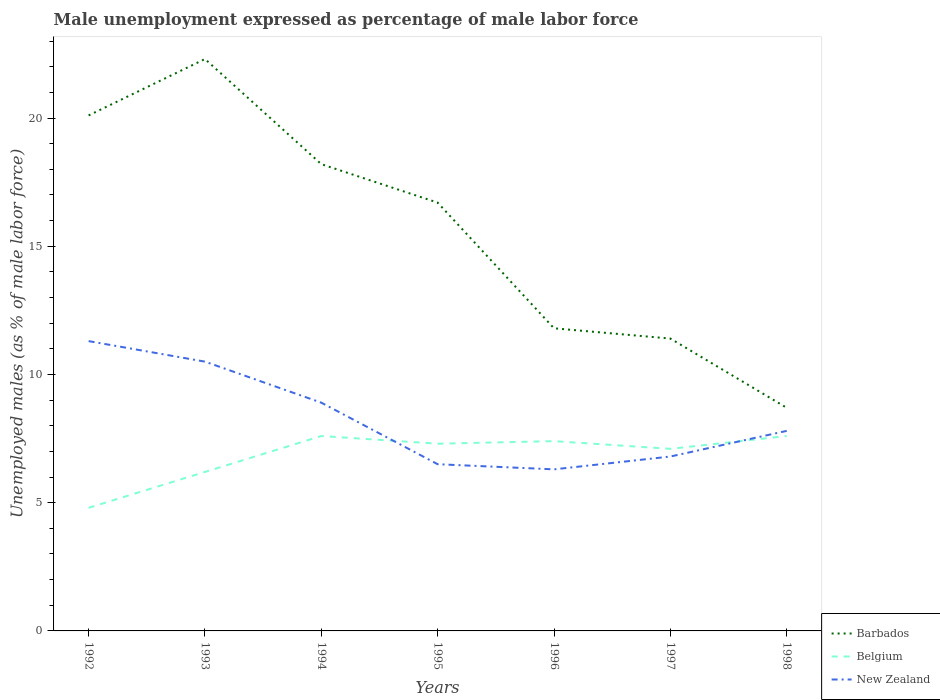Does the line corresponding to New Zealand intersect with the line corresponding to Barbados?
Offer a terse response. No. Is the number of lines equal to the number of legend labels?
Provide a succinct answer. Yes. Across all years, what is the maximum unemployment in males in in New Zealand?
Ensure brevity in your answer.  6.3. What is the total unemployment in males in in Barbados in the graph?
Make the answer very short. 13.6. What is the difference between the highest and the second highest unemployment in males in in Barbados?
Give a very brief answer. 13.6. Is the unemployment in males in in Belgium strictly greater than the unemployment in males in in New Zealand over the years?
Provide a succinct answer. No. How many lines are there?
Provide a short and direct response. 3. How many years are there in the graph?
Ensure brevity in your answer.  7. Are the values on the major ticks of Y-axis written in scientific E-notation?
Your answer should be very brief. No. What is the title of the graph?
Your answer should be very brief. Male unemployment expressed as percentage of male labor force. What is the label or title of the X-axis?
Your answer should be compact. Years. What is the label or title of the Y-axis?
Offer a very short reply. Unemployed males (as % of male labor force). What is the Unemployed males (as % of male labor force) of Barbados in 1992?
Keep it short and to the point. 20.1. What is the Unemployed males (as % of male labor force) in Belgium in 1992?
Your response must be concise. 4.8. What is the Unemployed males (as % of male labor force) of New Zealand in 1992?
Provide a short and direct response. 11.3. What is the Unemployed males (as % of male labor force) of Barbados in 1993?
Ensure brevity in your answer.  22.3. What is the Unemployed males (as % of male labor force) of Belgium in 1993?
Your answer should be very brief. 6.2. What is the Unemployed males (as % of male labor force) in Barbados in 1994?
Your answer should be compact. 18.2. What is the Unemployed males (as % of male labor force) of Belgium in 1994?
Your answer should be very brief. 7.6. What is the Unemployed males (as % of male labor force) in New Zealand in 1994?
Offer a terse response. 8.9. What is the Unemployed males (as % of male labor force) of Barbados in 1995?
Make the answer very short. 16.7. What is the Unemployed males (as % of male labor force) of Belgium in 1995?
Give a very brief answer. 7.3. What is the Unemployed males (as % of male labor force) in Barbados in 1996?
Offer a terse response. 11.8. What is the Unemployed males (as % of male labor force) in Belgium in 1996?
Offer a very short reply. 7.4. What is the Unemployed males (as % of male labor force) in New Zealand in 1996?
Provide a succinct answer. 6.3. What is the Unemployed males (as % of male labor force) of Barbados in 1997?
Provide a succinct answer. 11.4. What is the Unemployed males (as % of male labor force) of Belgium in 1997?
Your answer should be compact. 7.1. What is the Unemployed males (as % of male labor force) of New Zealand in 1997?
Keep it short and to the point. 6.8. What is the Unemployed males (as % of male labor force) of Barbados in 1998?
Your answer should be very brief. 8.7. What is the Unemployed males (as % of male labor force) in Belgium in 1998?
Your answer should be very brief. 7.6. What is the Unemployed males (as % of male labor force) in New Zealand in 1998?
Provide a succinct answer. 7.8. Across all years, what is the maximum Unemployed males (as % of male labor force) in Barbados?
Provide a succinct answer. 22.3. Across all years, what is the maximum Unemployed males (as % of male labor force) in Belgium?
Keep it short and to the point. 7.6. Across all years, what is the maximum Unemployed males (as % of male labor force) in New Zealand?
Your answer should be very brief. 11.3. Across all years, what is the minimum Unemployed males (as % of male labor force) of Barbados?
Make the answer very short. 8.7. Across all years, what is the minimum Unemployed males (as % of male labor force) of Belgium?
Give a very brief answer. 4.8. Across all years, what is the minimum Unemployed males (as % of male labor force) in New Zealand?
Offer a very short reply. 6.3. What is the total Unemployed males (as % of male labor force) in Barbados in the graph?
Your answer should be very brief. 109.2. What is the total Unemployed males (as % of male labor force) in New Zealand in the graph?
Provide a succinct answer. 58.1. What is the difference between the Unemployed males (as % of male labor force) of Barbados in 1992 and that in 1993?
Your answer should be very brief. -2.2. What is the difference between the Unemployed males (as % of male labor force) of New Zealand in 1992 and that in 1993?
Your answer should be compact. 0.8. What is the difference between the Unemployed males (as % of male labor force) of Barbados in 1992 and that in 1994?
Offer a very short reply. 1.9. What is the difference between the Unemployed males (as % of male labor force) in Belgium in 1992 and that in 1994?
Provide a short and direct response. -2.8. What is the difference between the Unemployed males (as % of male labor force) in New Zealand in 1992 and that in 1994?
Offer a terse response. 2.4. What is the difference between the Unemployed males (as % of male labor force) of New Zealand in 1992 and that in 1995?
Ensure brevity in your answer.  4.8. What is the difference between the Unemployed males (as % of male labor force) of Barbados in 1992 and that in 1996?
Make the answer very short. 8.3. What is the difference between the Unemployed males (as % of male labor force) of Belgium in 1992 and that in 1996?
Provide a short and direct response. -2.6. What is the difference between the Unemployed males (as % of male labor force) of Barbados in 1992 and that in 1997?
Keep it short and to the point. 8.7. What is the difference between the Unemployed males (as % of male labor force) of New Zealand in 1992 and that in 1997?
Your response must be concise. 4.5. What is the difference between the Unemployed males (as % of male labor force) in Belgium in 1992 and that in 1998?
Keep it short and to the point. -2.8. What is the difference between the Unemployed males (as % of male labor force) in Barbados in 1993 and that in 1994?
Make the answer very short. 4.1. What is the difference between the Unemployed males (as % of male labor force) of New Zealand in 1993 and that in 1994?
Keep it short and to the point. 1.6. What is the difference between the Unemployed males (as % of male labor force) of Barbados in 1993 and that in 1995?
Provide a short and direct response. 5.6. What is the difference between the Unemployed males (as % of male labor force) of New Zealand in 1993 and that in 1995?
Give a very brief answer. 4. What is the difference between the Unemployed males (as % of male labor force) of Belgium in 1993 and that in 1996?
Provide a succinct answer. -1.2. What is the difference between the Unemployed males (as % of male labor force) of New Zealand in 1993 and that in 1996?
Offer a terse response. 4.2. What is the difference between the Unemployed males (as % of male labor force) in Belgium in 1993 and that in 1997?
Offer a terse response. -0.9. What is the difference between the Unemployed males (as % of male labor force) of New Zealand in 1993 and that in 1997?
Ensure brevity in your answer.  3.7. What is the difference between the Unemployed males (as % of male labor force) in Barbados in 1993 and that in 1998?
Offer a very short reply. 13.6. What is the difference between the Unemployed males (as % of male labor force) of Belgium in 1993 and that in 1998?
Provide a succinct answer. -1.4. What is the difference between the Unemployed males (as % of male labor force) of Barbados in 1994 and that in 1995?
Provide a succinct answer. 1.5. What is the difference between the Unemployed males (as % of male labor force) in New Zealand in 1994 and that in 1995?
Offer a terse response. 2.4. What is the difference between the Unemployed males (as % of male labor force) in Barbados in 1994 and that in 1996?
Offer a very short reply. 6.4. What is the difference between the Unemployed males (as % of male labor force) in Belgium in 1994 and that in 1996?
Offer a terse response. 0.2. What is the difference between the Unemployed males (as % of male labor force) in New Zealand in 1994 and that in 1996?
Your answer should be compact. 2.6. What is the difference between the Unemployed males (as % of male labor force) of Barbados in 1994 and that in 1997?
Ensure brevity in your answer.  6.8. What is the difference between the Unemployed males (as % of male labor force) in Belgium in 1994 and that in 1997?
Keep it short and to the point. 0.5. What is the difference between the Unemployed males (as % of male labor force) in New Zealand in 1994 and that in 1997?
Provide a succinct answer. 2.1. What is the difference between the Unemployed males (as % of male labor force) of Barbados in 1994 and that in 1998?
Offer a very short reply. 9.5. What is the difference between the Unemployed males (as % of male labor force) in New Zealand in 1994 and that in 1998?
Make the answer very short. 1.1. What is the difference between the Unemployed males (as % of male labor force) in Barbados in 1995 and that in 1997?
Ensure brevity in your answer.  5.3. What is the difference between the Unemployed males (as % of male labor force) in Barbados in 1995 and that in 1998?
Offer a terse response. 8. What is the difference between the Unemployed males (as % of male labor force) in Belgium in 1996 and that in 1997?
Give a very brief answer. 0.3. What is the difference between the Unemployed males (as % of male labor force) in New Zealand in 1996 and that in 1997?
Give a very brief answer. -0.5. What is the difference between the Unemployed males (as % of male labor force) in Belgium in 1997 and that in 1998?
Your answer should be compact. -0.5. What is the difference between the Unemployed males (as % of male labor force) of Barbados in 1992 and the Unemployed males (as % of male labor force) of New Zealand in 1993?
Give a very brief answer. 9.6. What is the difference between the Unemployed males (as % of male labor force) in Barbados in 1992 and the Unemployed males (as % of male labor force) in New Zealand in 1994?
Keep it short and to the point. 11.2. What is the difference between the Unemployed males (as % of male labor force) of Belgium in 1992 and the Unemployed males (as % of male labor force) of New Zealand in 1994?
Ensure brevity in your answer.  -4.1. What is the difference between the Unemployed males (as % of male labor force) in Belgium in 1992 and the Unemployed males (as % of male labor force) in New Zealand in 1995?
Provide a short and direct response. -1.7. What is the difference between the Unemployed males (as % of male labor force) in Barbados in 1992 and the Unemployed males (as % of male labor force) in New Zealand in 1996?
Provide a succinct answer. 13.8. What is the difference between the Unemployed males (as % of male labor force) of Belgium in 1992 and the Unemployed males (as % of male labor force) of New Zealand in 1996?
Offer a very short reply. -1.5. What is the difference between the Unemployed males (as % of male labor force) of Barbados in 1992 and the Unemployed males (as % of male labor force) of New Zealand in 1997?
Keep it short and to the point. 13.3. What is the difference between the Unemployed males (as % of male labor force) of Belgium in 1992 and the Unemployed males (as % of male labor force) of New Zealand in 1997?
Your response must be concise. -2. What is the difference between the Unemployed males (as % of male labor force) of Barbados in 1992 and the Unemployed males (as % of male labor force) of New Zealand in 1998?
Offer a terse response. 12.3. What is the difference between the Unemployed males (as % of male labor force) of Barbados in 1993 and the Unemployed males (as % of male labor force) of New Zealand in 1994?
Offer a terse response. 13.4. What is the difference between the Unemployed males (as % of male labor force) in Belgium in 1993 and the Unemployed males (as % of male labor force) in New Zealand in 1995?
Your answer should be very brief. -0.3. What is the difference between the Unemployed males (as % of male labor force) of Barbados in 1993 and the Unemployed males (as % of male labor force) of New Zealand in 1996?
Offer a terse response. 16. What is the difference between the Unemployed males (as % of male labor force) of Belgium in 1993 and the Unemployed males (as % of male labor force) of New Zealand in 1997?
Your answer should be compact. -0.6. What is the difference between the Unemployed males (as % of male labor force) in Barbados in 1993 and the Unemployed males (as % of male labor force) in Belgium in 1998?
Make the answer very short. 14.7. What is the difference between the Unemployed males (as % of male labor force) in Barbados in 1993 and the Unemployed males (as % of male labor force) in New Zealand in 1998?
Your answer should be very brief. 14.5. What is the difference between the Unemployed males (as % of male labor force) in Barbados in 1994 and the Unemployed males (as % of male labor force) in Belgium in 1998?
Give a very brief answer. 10.6. What is the difference between the Unemployed males (as % of male labor force) in Barbados in 1995 and the Unemployed males (as % of male labor force) in Belgium in 1996?
Offer a terse response. 9.3. What is the difference between the Unemployed males (as % of male labor force) of Barbados in 1995 and the Unemployed males (as % of male labor force) of New Zealand in 1996?
Ensure brevity in your answer.  10.4. What is the difference between the Unemployed males (as % of male labor force) in Belgium in 1995 and the Unemployed males (as % of male labor force) in New Zealand in 1996?
Your response must be concise. 1. What is the difference between the Unemployed males (as % of male labor force) in Barbados in 1995 and the Unemployed males (as % of male labor force) in Belgium in 1997?
Give a very brief answer. 9.6. What is the difference between the Unemployed males (as % of male labor force) in Belgium in 1995 and the Unemployed males (as % of male labor force) in New Zealand in 1997?
Your answer should be very brief. 0.5. What is the difference between the Unemployed males (as % of male labor force) in Barbados in 1996 and the Unemployed males (as % of male labor force) in New Zealand in 1997?
Your answer should be very brief. 5. What is the difference between the Unemployed males (as % of male labor force) in Barbados in 1996 and the Unemployed males (as % of male labor force) in Belgium in 1998?
Offer a terse response. 4.2. What is the difference between the Unemployed males (as % of male labor force) of Barbados in 1996 and the Unemployed males (as % of male labor force) of New Zealand in 1998?
Offer a terse response. 4. What is the difference between the Unemployed males (as % of male labor force) in Barbados in 1997 and the Unemployed males (as % of male labor force) in New Zealand in 1998?
Your response must be concise. 3.6. What is the difference between the Unemployed males (as % of male labor force) in Belgium in 1997 and the Unemployed males (as % of male labor force) in New Zealand in 1998?
Offer a very short reply. -0.7. What is the average Unemployed males (as % of male labor force) in Belgium per year?
Keep it short and to the point. 6.86. What is the average Unemployed males (as % of male labor force) of New Zealand per year?
Provide a short and direct response. 8.3. In the year 1992, what is the difference between the Unemployed males (as % of male labor force) of Barbados and Unemployed males (as % of male labor force) of Belgium?
Make the answer very short. 15.3. In the year 1992, what is the difference between the Unemployed males (as % of male labor force) of Barbados and Unemployed males (as % of male labor force) of New Zealand?
Your answer should be compact. 8.8. In the year 1993, what is the difference between the Unemployed males (as % of male labor force) of Barbados and Unemployed males (as % of male labor force) of New Zealand?
Keep it short and to the point. 11.8. In the year 1993, what is the difference between the Unemployed males (as % of male labor force) of Belgium and Unemployed males (as % of male labor force) of New Zealand?
Your answer should be very brief. -4.3. In the year 1995, what is the difference between the Unemployed males (as % of male labor force) of Barbados and Unemployed males (as % of male labor force) of Belgium?
Your answer should be compact. 9.4. In the year 1997, what is the difference between the Unemployed males (as % of male labor force) of Barbados and Unemployed males (as % of male labor force) of Belgium?
Give a very brief answer. 4.3. In the year 1997, what is the difference between the Unemployed males (as % of male labor force) in Belgium and Unemployed males (as % of male labor force) in New Zealand?
Offer a terse response. 0.3. In the year 1998, what is the difference between the Unemployed males (as % of male labor force) in Barbados and Unemployed males (as % of male labor force) in Belgium?
Provide a succinct answer. 1.1. In the year 1998, what is the difference between the Unemployed males (as % of male labor force) in Barbados and Unemployed males (as % of male labor force) in New Zealand?
Your answer should be very brief. 0.9. In the year 1998, what is the difference between the Unemployed males (as % of male labor force) in Belgium and Unemployed males (as % of male labor force) in New Zealand?
Ensure brevity in your answer.  -0.2. What is the ratio of the Unemployed males (as % of male labor force) in Barbados in 1992 to that in 1993?
Provide a short and direct response. 0.9. What is the ratio of the Unemployed males (as % of male labor force) of Belgium in 1992 to that in 1993?
Your answer should be very brief. 0.77. What is the ratio of the Unemployed males (as % of male labor force) in New Zealand in 1992 to that in 1993?
Your answer should be compact. 1.08. What is the ratio of the Unemployed males (as % of male labor force) in Barbados in 1992 to that in 1994?
Keep it short and to the point. 1.1. What is the ratio of the Unemployed males (as % of male labor force) of Belgium in 1992 to that in 1994?
Keep it short and to the point. 0.63. What is the ratio of the Unemployed males (as % of male labor force) in New Zealand in 1992 to that in 1994?
Provide a short and direct response. 1.27. What is the ratio of the Unemployed males (as % of male labor force) in Barbados in 1992 to that in 1995?
Your answer should be very brief. 1.2. What is the ratio of the Unemployed males (as % of male labor force) of Belgium in 1992 to that in 1995?
Your answer should be very brief. 0.66. What is the ratio of the Unemployed males (as % of male labor force) of New Zealand in 1992 to that in 1995?
Your answer should be very brief. 1.74. What is the ratio of the Unemployed males (as % of male labor force) in Barbados in 1992 to that in 1996?
Provide a short and direct response. 1.7. What is the ratio of the Unemployed males (as % of male labor force) in Belgium in 1992 to that in 1996?
Provide a short and direct response. 0.65. What is the ratio of the Unemployed males (as % of male labor force) of New Zealand in 1992 to that in 1996?
Keep it short and to the point. 1.79. What is the ratio of the Unemployed males (as % of male labor force) in Barbados in 1992 to that in 1997?
Give a very brief answer. 1.76. What is the ratio of the Unemployed males (as % of male labor force) in Belgium in 1992 to that in 1997?
Give a very brief answer. 0.68. What is the ratio of the Unemployed males (as % of male labor force) in New Zealand in 1992 to that in 1997?
Ensure brevity in your answer.  1.66. What is the ratio of the Unemployed males (as % of male labor force) of Barbados in 1992 to that in 1998?
Ensure brevity in your answer.  2.31. What is the ratio of the Unemployed males (as % of male labor force) in Belgium in 1992 to that in 1998?
Offer a terse response. 0.63. What is the ratio of the Unemployed males (as % of male labor force) of New Zealand in 1992 to that in 1998?
Keep it short and to the point. 1.45. What is the ratio of the Unemployed males (as % of male labor force) in Barbados in 1993 to that in 1994?
Provide a succinct answer. 1.23. What is the ratio of the Unemployed males (as % of male labor force) in Belgium in 1993 to that in 1994?
Provide a short and direct response. 0.82. What is the ratio of the Unemployed males (as % of male labor force) of New Zealand in 1993 to that in 1994?
Make the answer very short. 1.18. What is the ratio of the Unemployed males (as % of male labor force) of Barbados in 1993 to that in 1995?
Make the answer very short. 1.34. What is the ratio of the Unemployed males (as % of male labor force) in Belgium in 1993 to that in 1995?
Keep it short and to the point. 0.85. What is the ratio of the Unemployed males (as % of male labor force) in New Zealand in 1993 to that in 1995?
Ensure brevity in your answer.  1.62. What is the ratio of the Unemployed males (as % of male labor force) of Barbados in 1993 to that in 1996?
Keep it short and to the point. 1.89. What is the ratio of the Unemployed males (as % of male labor force) of Belgium in 1993 to that in 1996?
Offer a very short reply. 0.84. What is the ratio of the Unemployed males (as % of male labor force) of Barbados in 1993 to that in 1997?
Your response must be concise. 1.96. What is the ratio of the Unemployed males (as % of male labor force) in Belgium in 1993 to that in 1997?
Keep it short and to the point. 0.87. What is the ratio of the Unemployed males (as % of male labor force) in New Zealand in 1993 to that in 1997?
Provide a short and direct response. 1.54. What is the ratio of the Unemployed males (as % of male labor force) in Barbados in 1993 to that in 1998?
Offer a terse response. 2.56. What is the ratio of the Unemployed males (as % of male labor force) in Belgium in 1993 to that in 1998?
Offer a very short reply. 0.82. What is the ratio of the Unemployed males (as % of male labor force) in New Zealand in 1993 to that in 1998?
Keep it short and to the point. 1.35. What is the ratio of the Unemployed males (as % of male labor force) of Barbados in 1994 to that in 1995?
Provide a short and direct response. 1.09. What is the ratio of the Unemployed males (as % of male labor force) in Belgium in 1994 to that in 1995?
Ensure brevity in your answer.  1.04. What is the ratio of the Unemployed males (as % of male labor force) of New Zealand in 1994 to that in 1995?
Make the answer very short. 1.37. What is the ratio of the Unemployed males (as % of male labor force) of Barbados in 1994 to that in 1996?
Ensure brevity in your answer.  1.54. What is the ratio of the Unemployed males (as % of male labor force) in Belgium in 1994 to that in 1996?
Offer a very short reply. 1.03. What is the ratio of the Unemployed males (as % of male labor force) in New Zealand in 1994 to that in 1996?
Your answer should be very brief. 1.41. What is the ratio of the Unemployed males (as % of male labor force) of Barbados in 1994 to that in 1997?
Ensure brevity in your answer.  1.6. What is the ratio of the Unemployed males (as % of male labor force) in Belgium in 1994 to that in 1997?
Keep it short and to the point. 1.07. What is the ratio of the Unemployed males (as % of male labor force) of New Zealand in 1994 to that in 1997?
Provide a succinct answer. 1.31. What is the ratio of the Unemployed males (as % of male labor force) in Barbados in 1994 to that in 1998?
Your answer should be very brief. 2.09. What is the ratio of the Unemployed males (as % of male labor force) in Belgium in 1994 to that in 1998?
Give a very brief answer. 1. What is the ratio of the Unemployed males (as % of male labor force) of New Zealand in 1994 to that in 1998?
Ensure brevity in your answer.  1.14. What is the ratio of the Unemployed males (as % of male labor force) in Barbados in 1995 to that in 1996?
Your answer should be very brief. 1.42. What is the ratio of the Unemployed males (as % of male labor force) in Belgium in 1995 to that in 1996?
Make the answer very short. 0.99. What is the ratio of the Unemployed males (as % of male labor force) of New Zealand in 1995 to that in 1996?
Offer a very short reply. 1.03. What is the ratio of the Unemployed males (as % of male labor force) in Barbados in 1995 to that in 1997?
Ensure brevity in your answer.  1.46. What is the ratio of the Unemployed males (as % of male labor force) of Belgium in 1995 to that in 1997?
Your answer should be very brief. 1.03. What is the ratio of the Unemployed males (as % of male labor force) of New Zealand in 1995 to that in 1997?
Give a very brief answer. 0.96. What is the ratio of the Unemployed males (as % of male labor force) of Barbados in 1995 to that in 1998?
Your answer should be compact. 1.92. What is the ratio of the Unemployed males (as % of male labor force) of Belgium in 1995 to that in 1998?
Your answer should be very brief. 0.96. What is the ratio of the Unemployed males (as % of male labor force) in Barbados in 1996 to that in 1997?
Your answer should be very brief. 1.04. What is the ratio of the Unemployed males (as % of male labor force) of Belgium in 1996 to that in 1997?
Provide a short and direct response. 1.04. What is the ratio of the Unemployed males (as % of male labor force) in New Zealand in 1996 to that in 1997?
Keep it short and to the point. 0.93. What is the ratio of the Unemployed males (as % of male labor force) in Barbados in 1996 to that in 1998?
Provide a short and direct response. 1.36. What is the ratio of the Unemployed males (as % of male labor force) in Belgium in 1996 to that in 1998?
Ensure brevity in your answer.  0.97. What is the ratio of the Unemployed males (as % of male labor force) in New Zealand in 1996 to that in 1998?
Offer a terse response. 0.81. What is the ratio of the Unemployed males (as % of male labor force) in Barbados in 1997 to that in 1998?
Provide a short and direct response. 1.31. What is the ratio of the Unemployed males (as % of male labor force) of Belgium in 1997 to that in 1998?
Offer a terse response. 0.93. What is the ratio of the Unemployed males (as % of male labor force) of New Zealand in 1997 to that in 1998?
Offer a terse response. 0.87. What is the difference between the highest and the lowest Unemployed males (as % of male labor force) in Belgium?
Offer a terse response. 2.8. 